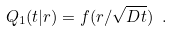<formula> <loc_0><loc_0><loc_500><loc_500>Q _ { 1 } ( t | r ) = f ( r / \sqrt { D t } ) \ .</formula> 